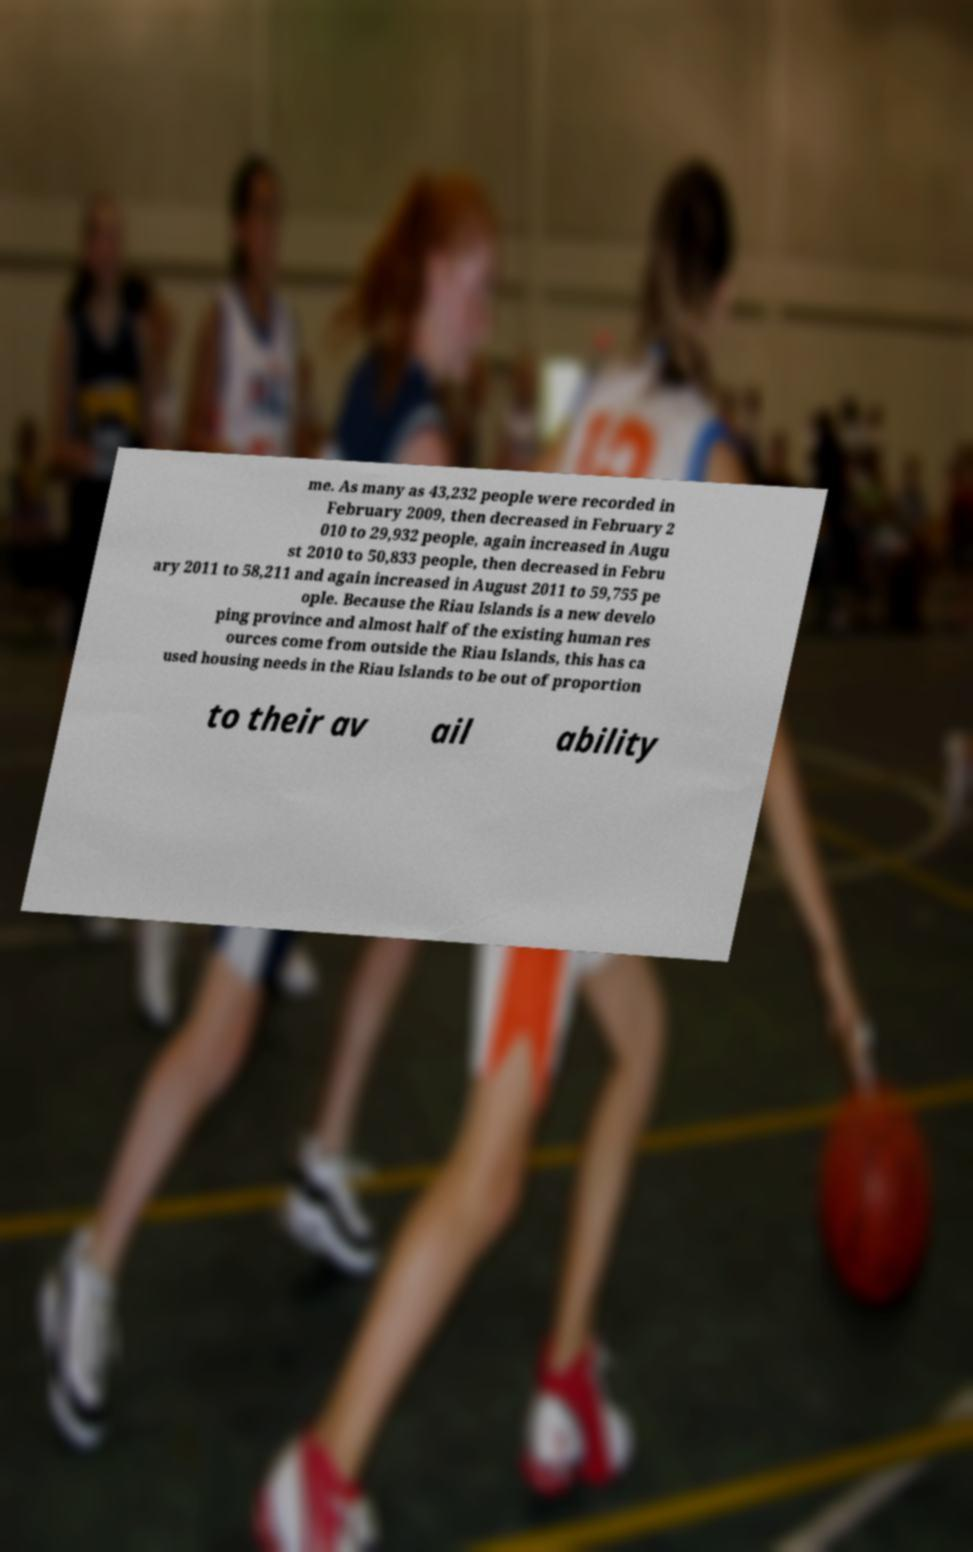What messages or text are displayed in this image? I need them in a readable, typed format. me. As many as 43,232 people were recorded in February 2009, then decreased in February 2 010 to 29,932 people, again increased in Augu st 2010 to 50,833 people, then decreased in Febru ary 2011 to 58,211 and again increased in August 2011 to 59,755 pe ople. Because the Riau Islands is a new develo ping province and almost half of the existing human res ources come from outside the Riau Islands, this has ca used housing needs in the Riau Islands to be out of proportion to their av ail ability 